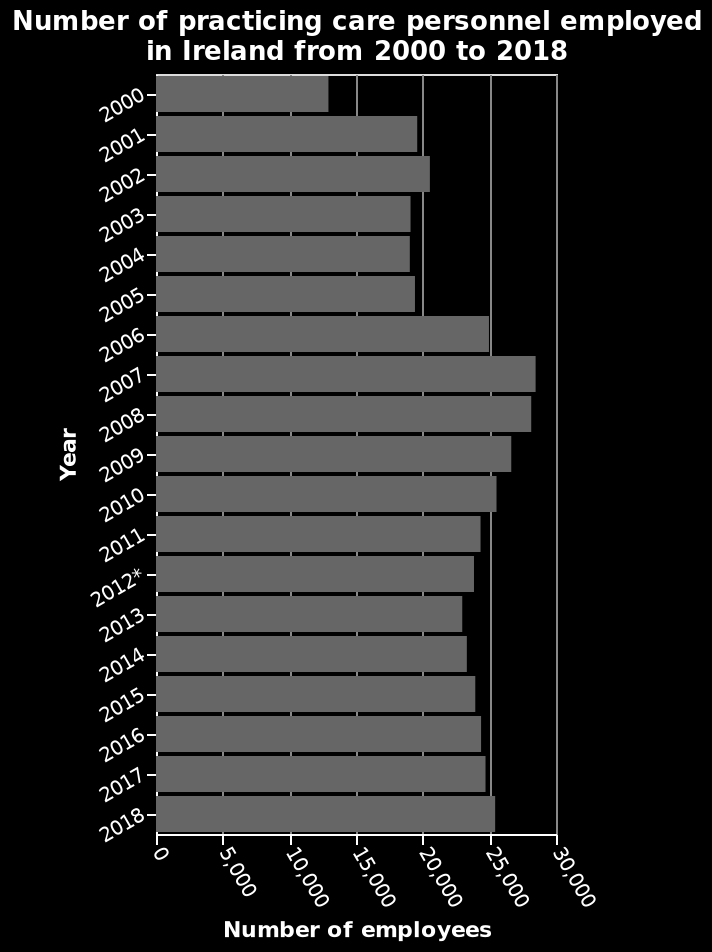<image>
Offer a thorough analysis of the image. There was an increase in practising care personnel in Ireland from 2000 to 2001. Since 2001 the number of practising care personnel in Ireland has very slowly increased until 2018. There was a spike in care personnel in 2007. What type of scale is used for the measurement on the y-axis? A linear scale is used for the measurement on the y-axis. Did the number of practising care personnel in Ireland decrease after 2007? No, the number of practising care personnel in Ireland has been slowly increasing since 2007. 